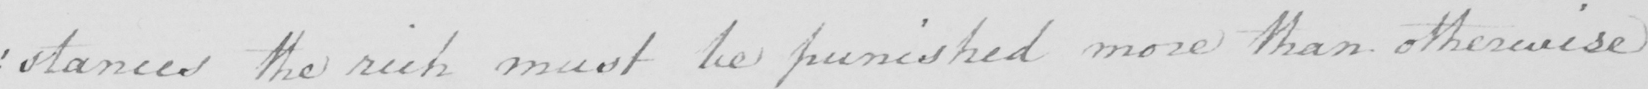Can you read and transcribe this handwriting? : stances the rich must be punished more than otherwise 